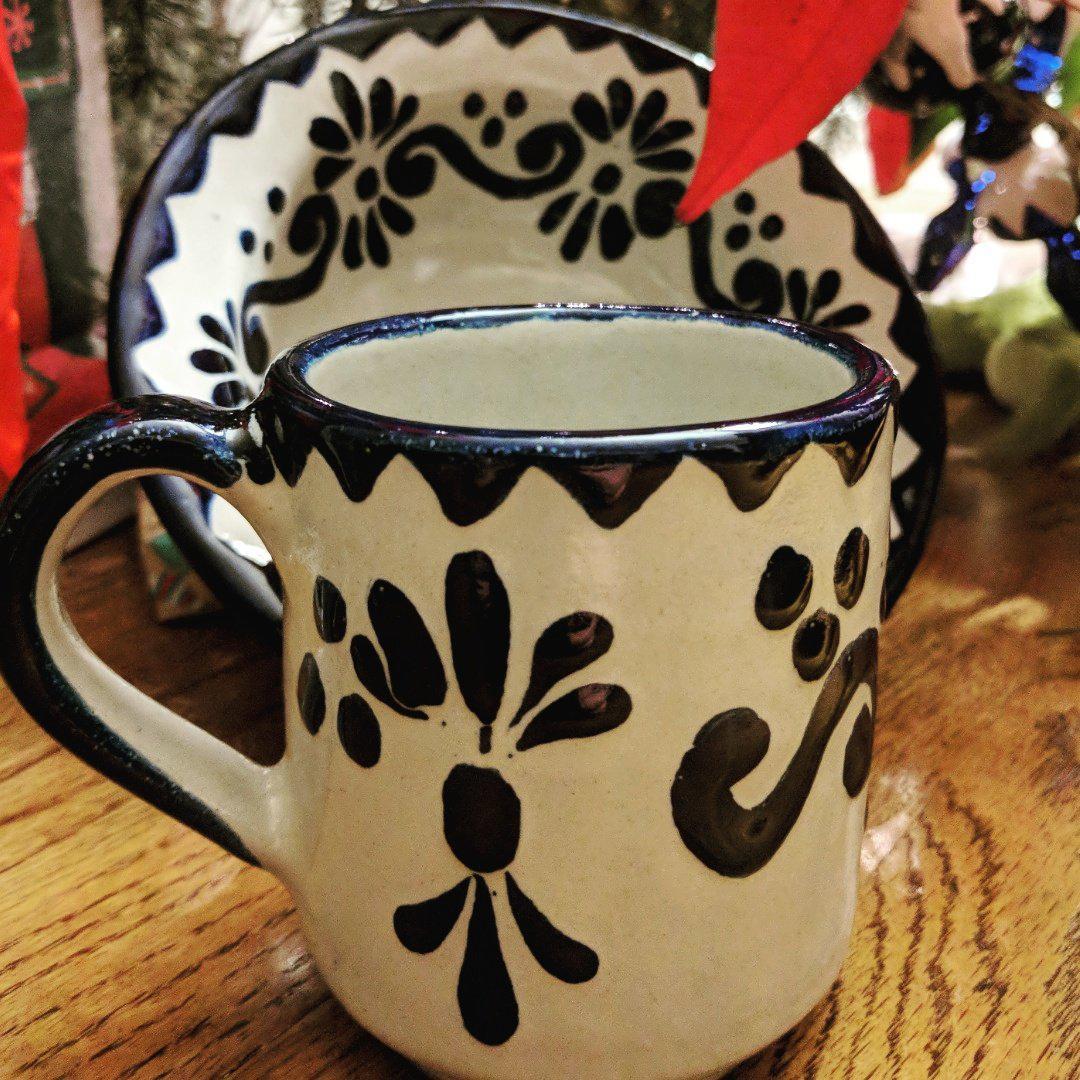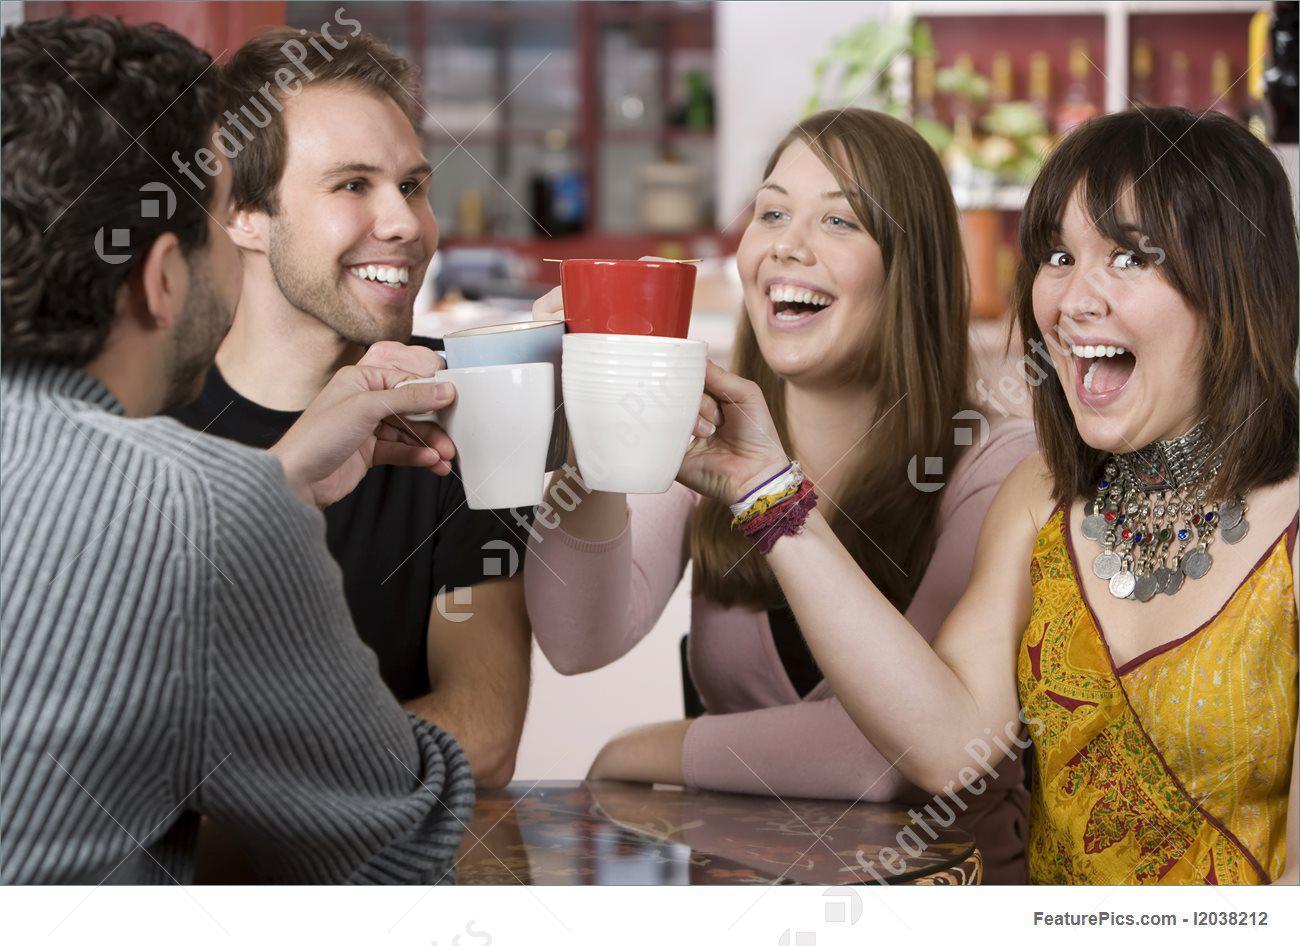The first image is the image on the left, the second image is the image on the right. Assess this claim about the two images: "There are exactly four cups.". Correct or not? Answer yes or no. No. The first image is the image on the left, the second image is the image on the right. Evaluate the accuracy of this statement regarding the images: "At least three people are drinking from mugs together in the image on the right.". Is it true? Answer yes or no. Yes. 